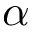<formula> <loc_0><loc_0><loc_500><loc_500>\alpha</formula> 